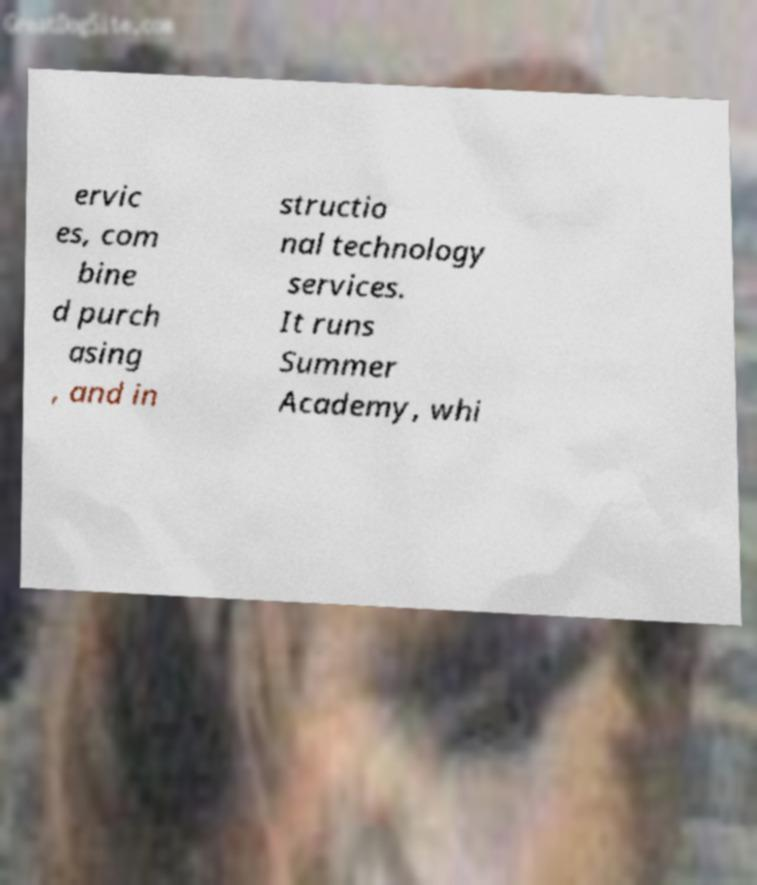Please read and relay the text visible in this image. What does it say? ervic es, com bine d purch asing , and in structio nal technology services. It runs Summer Academy, whi 